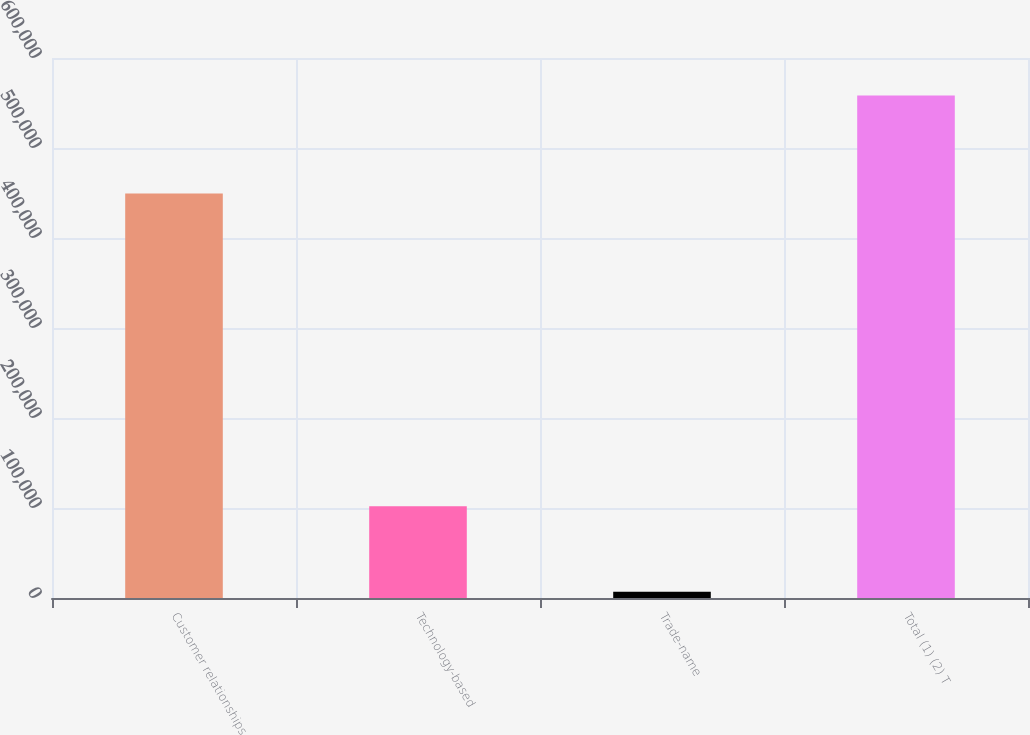Convert chart. <chart><loc_0><loc_0><loc_500><loc_500><bar_chart><fcel>Customer relationships<fcel>Technology-based<fcel>Trade-name<fcel>Total (1) (2) T<nl><fcel>449369<fcel>101920<fcel>6906<fcel>558395<nl></chart> 